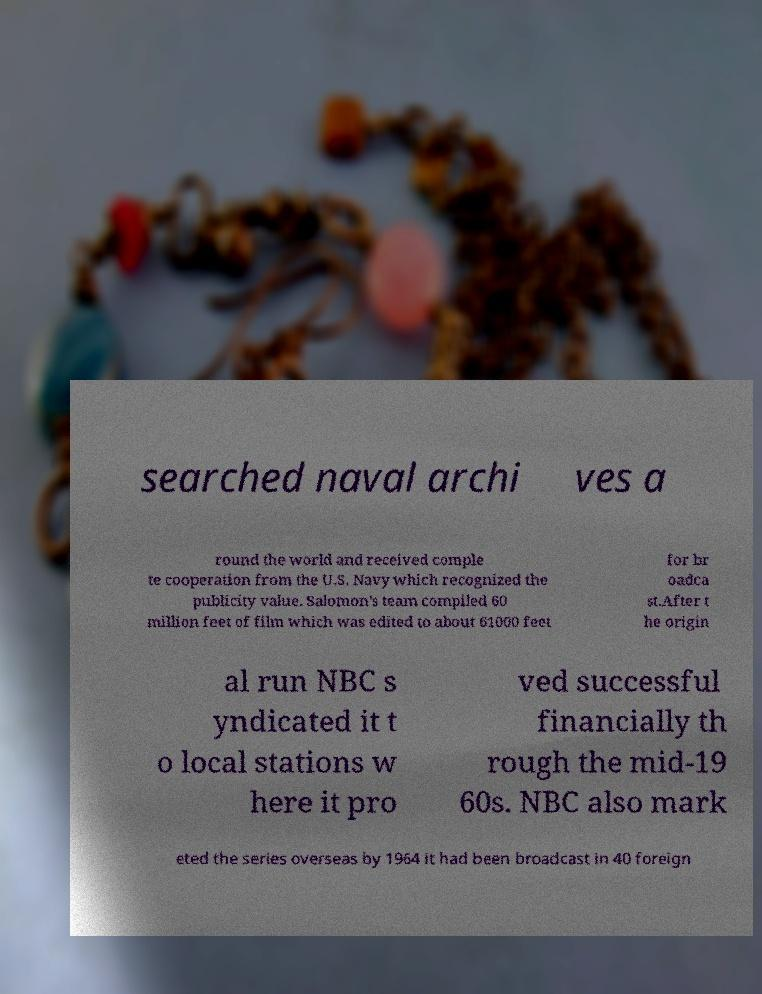Could you extract and type out the text from this image? searched naval archi ves a round the world and received comple te cooperation from the U.S. Navy which recognized the publicity value. Salomon's team compiled 60 million feet of film which was edited to about 61000 feet for br oadca st.After t he origin al run NBC s yndicated it t o local stations w here it pro ved successful financially th rough the mid-19 60s. NBC also mark eted the series overseas by 1964 it had been broadcast in 40 foreign 